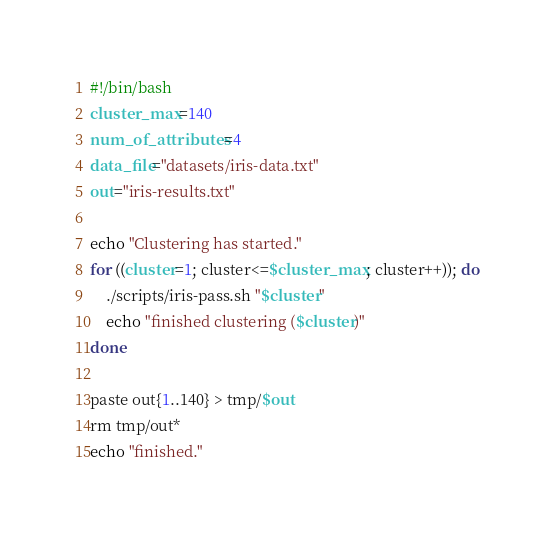<code> <loc_0><loc_0><loc_500><loc_500><_Bash_>#!/bin/bash
cluster_max=140
num_of_attributes=4
data_file="datasets/iris-data.txt"
out="iris-results.txt"

echo "Clustering has started."
for ((cluster=1; cluster<=$cluster_max; cluster++)); do
	./scripts/iris-pass.sh "$cluster"
	echo "finished clustering ($cluster)"
done

paste out{1..140} > tmp/$out
rm tmp/out*
echo "finished."
</code> 